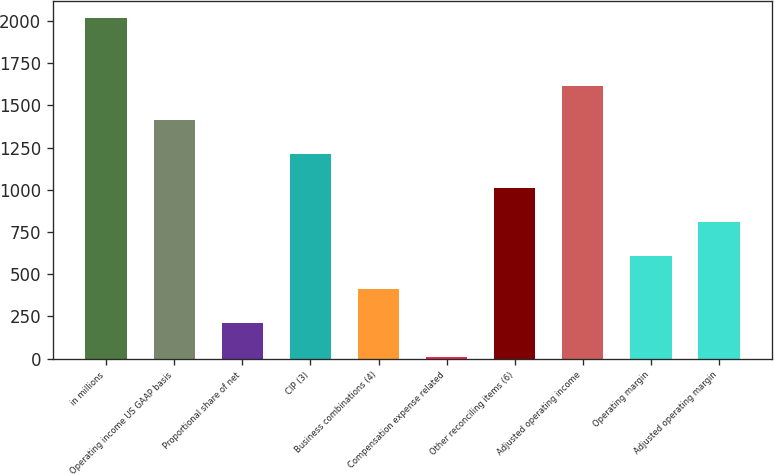Convert chart. <chart><loc_0><loc_0><loc_500><loc_500><bar_chart><fcel>in millions<fcel>Operating income US GAAP basis<fcel>Proportional share of net<fcel>CIP (3)<fcel>Business combinations (4)<fcel>Compensation expense related<fcel>Other reconciling items (6)<fcel>Adjusted operating income<fcel>Operating margin<fcel>Adjusted operating margin<nl><fcel>2016<fcel>1413.63<fcel>208.89<fcel>1212.84<fcel>409.68<fcel>8.1<fcel>1012.05<fcel>1614.42<fcel>610.47<fcel>811.26<nl></chart> 